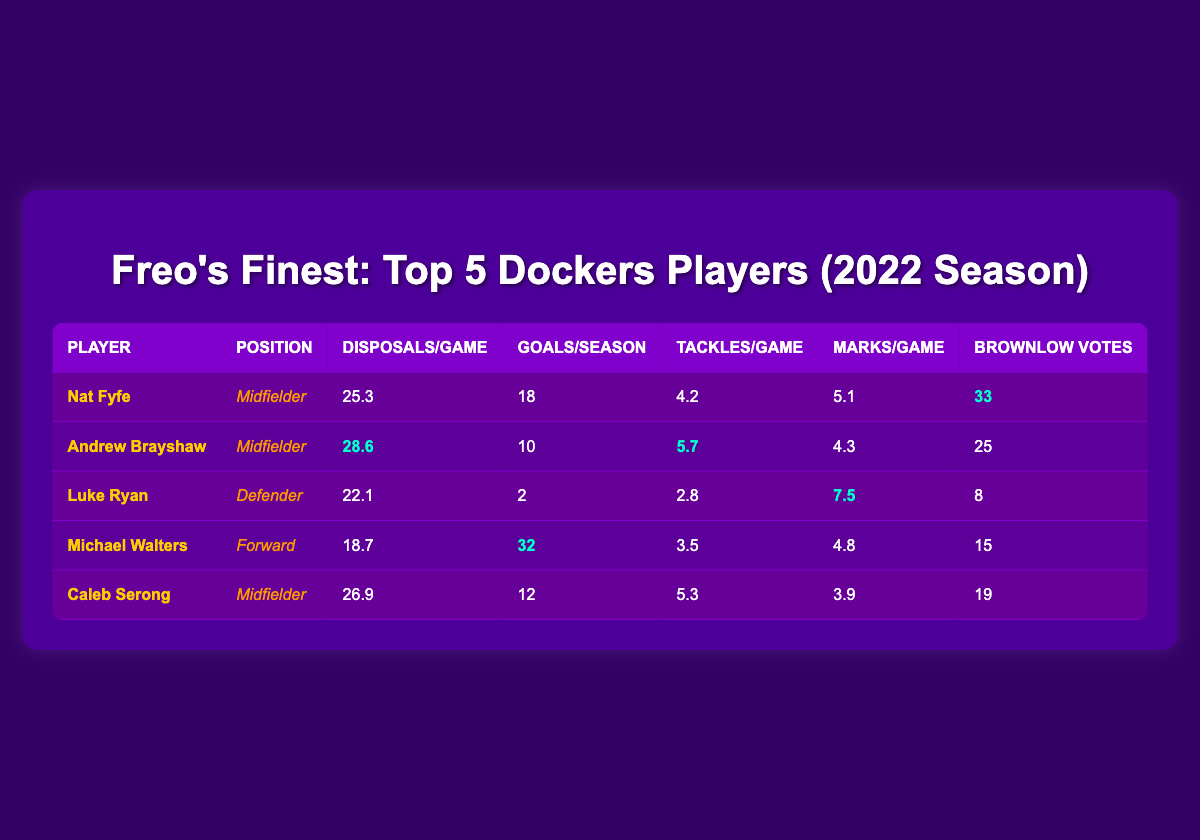What is the total number of goals scored by all players combined? To find the total number of goals, we sum the goals for each player: 18 (Nat Fyfe) + 10 (Andrew Brayshaw) + 2 (Luke Ryan) + 32 (Michael Walters) + 12 (Caleb Serong) = 74.
Answer: 74 Which player had the highest disposals per game? Looking at the disposals per game column, Andrew Brayshaw has the highest value at 28.6.
Answer: Andrew Brayshaw Did Luke Ryan have more tackles per game than Caleb Serong? Luke Ryan had 2.8 tackles per game while Caleb Serong had 5.3 tackles per game. Therefore, Luke Ryan had fewer tackles per game.
Answer: No What is the average number of brownlow votes for these players? To find the average, we sum the brownlow votes: 33 (Nat Fyfe) + 25 (Andrew Brayshaw) + 8 (Luke Ryan) + 15 (Michael Walters) + 19 (Caleb Serong) = 100. There are 5 players, so the average is 100/5 = 20.
Answer: 20 How many players are midfielders? By examining the position column, Nat Fyfe, Andrew Brayshaw, and Caleb Serong are listed as midfielders, which totals to 3 players.
Answer: 3 Which player has the lowest number of goals per season? Comparing the goals per season column, Luke Ryan has the lowest value at 2 goals.
Answer: Luke Ryan What is the difference in disposals per game between Nat Fyfe and Michael Walters? Nat Fyfe had 25.3 disposals per game and Michael Walters had 18.7. The difference is 25.3 - 18.7 = 6.6.
Answer: 6.6 Did any player achieve more than 30 goals in a season? Checking the goals per season column, Michael Walters scored 32 goals, which is more than 30, confirming the statement.
Answer: Yes What percentage of the total tackles do Andrew Brayshaw and Caleb Serong combined account for? We first find the total tackles: 4.2 (Nat Fyfe) + 5.7 (Andrew Brayshaw) + 2.8 (Luke Ryan) + 3.5 (Michael Walters) + 5.3 (Caleb Serong) = 21.5. The combined tackles of Andrew Brayshaw and Caleb Serong are 5.7 + 5.3 = 11. Thus, the percentage is (11/21.5) * 100 = 51.16%, which we round to 51.2%.
Answer: 51.2% 